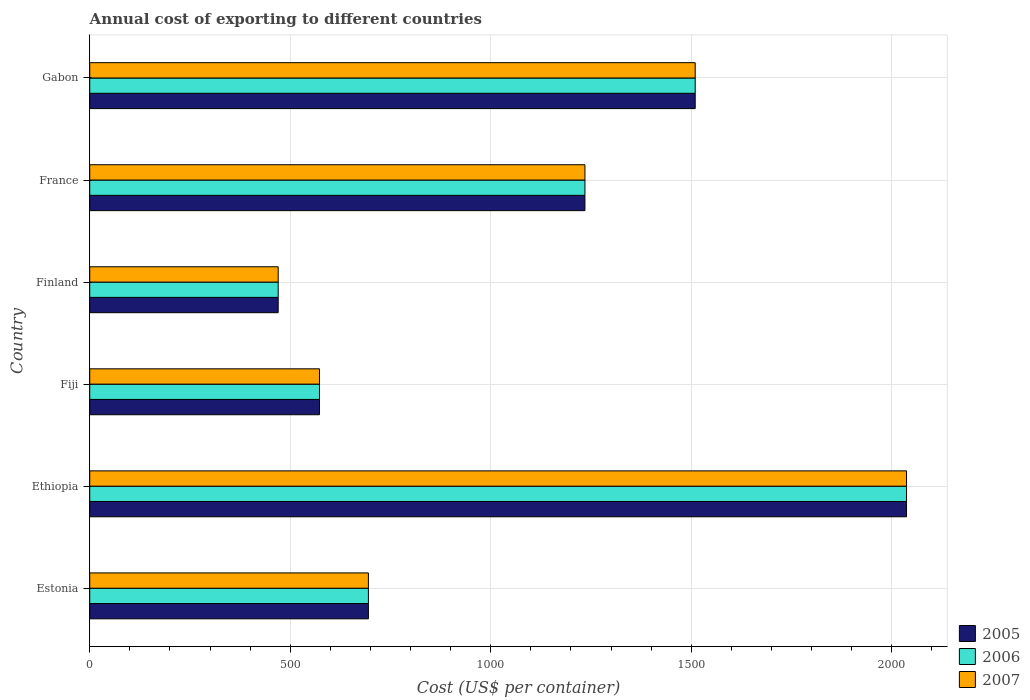How many different coloured bars are there?
Your response must be concise. 3. Are the number of bars per tick equal to the number of legend labels?
Ensure brevity in your answer.  Yes. Are the number of bars on each tick of the Y-axis equal?
Ensure brevity in your answer.  Yes. How many bars are there on the 5th tick from the bottom?
Give a very brief answer. 3. What is the label of the 4th group of bars from the top?
Offer a terse response. Fiji. What is the total annual cost of exporting in 2005 in Fiji?
Give a very brief answer. 573. Across all countries, what is the maximum total annual cost of exporting in 2007?
Provide a short and direct response. 2037. Across all countries, what is the minimum total annual cost of exporting in 2005?
Your answer should be very brief. 470. In which country was the total annual cost of exporting in 2006 maximum?
Ensure brevity in your answer.  Ethiopia. What is the total total annual cost of exporting in 2006 in the graph?
Your answer should be compact. 6520. What is the difference between the total annual cost of exporting in 2005 in Estonia and that in Ethiopia?
Make the answer very short. -1342. What is the difference between the total annual cost of exporting in 2005 in Gabon and the total annual cost of exporting in 2007 in Finland?
Your response must be concise. 1040. What is the average total annual cost of exporting in 2006 per country?
Keep it short and to the point. 1086.67. What is the difference between the total annual cost of exporting in 2007 and total annual cost of exporting in 2005 in Estonia?
Make the answer very short. 0. In how many countries, is the total annual cost of exporting in 2007 greater than 1600 US$?
Give a very brief answer. 1. What is the ratio of the total annual cost of exporting in 2006 in Fiji to that in Gabon?
Offer a terse response. 0.38. Is the total annual cost of exporting in 2006 in Fiji less than that in Finland?
Your answer should be compact. No. Is the difference between the total annual cost of exporting in 2007 in Estonia and Ethiopia greater than the difference between the total annual cost of exporting in 2005 in Estonia and Ethiopia?
Give a very brief answer. No. What is the difference between the highest and the second highest total annual cost of exporting in 2005?
Offer a very short reply. 527. What is the difference between the highest and the lowest total annual cost of exporting in 2007?
Provide a short and direct response. 1567. What does the 3rd bar from the top in Estonia represents?
Your answer should be very brief. 2005. What does the 1st bar from the bottom in Estonia represents?
Provide a short and direct response. 2005. Are all the bars in the graph horizontal?
Keep it short and to the point. Yes. How many countries are there in the graph?
Keep it short and to the point. 6. Does the graph contain any zero values?
Your answer should be compact. No. How are the legend labels stacked?
Keep it short and to the point. Vertical. What is the title of the graph?
Offer a terse response. Annual cost of exporting to different countries. What is the label or title of the X-axis?
Offer a very short reply. Cost (US$ per container). What is the Cost (US$ per container) in 2005 in Estonia?
Give a very brief answer. 695. What is the Cost (US$ per container) in 2006 in Estonia?
Ensure brevity in your answer.  695. What is the Cost (US$ per container) in 2007 in Estonia?
Make the answer very short. 695. What is the Cost (US$ per container) in 2005 in Ethiopia?
Offer a very short reply. 2037. What is the Cost (US$ per container) of 2006 in Ethiopia?
Provide a succinct answer. 2037. What is the Cost (US$ per container) in 2007 in Ethiopia?
Your answer should be very brief. 2037. What is the Cost (US$ per container) of 2005 in Fiji?
Offer a very short reply. 573. What is the Cost (US$ per container) in 2006 in Fiji?
Provide a succinct answer. 573. What is the Cost (US$ per container) in 2007 in Fiji?
Provide a succinct answer. 573. What is the Cost (US$ per container) of 2005 in Finland?
Provide a succinct answer. 470. What is the Cost (US$ per container) in 2006 in Finland?
Ensure brevity in your answer.  470. What is the Cost (US$ per container) of 2007 in Finland?
Offer a very short reply. 470. What is the Cost (US$ per container) of 2005 in France?
Your answer should be very brief. 1235. What is the Cost (US$ per container) of 2006 in France?
Provide a short and direct response. 1235. What is the Cost (US$ per container) in 2007 in France?
Provide a short and direct response. 1235. What is the Cost (US$ per container) of 2005 in Gabon?
Keep it short and to the point. 1510. What is the Cost (US$ per container) in 2006 in Gabon?
Provide a succinct answer. 1510. What is the Cost (US$ per container) of 2007 in Gabon?
Ensure brevity in your answer.  1510. Across all countries, what is the maximum Cost (US$ per container) in 2005?
Offer a terse response. 2037. Across all countries, what is the maximum Cost (US$ per container) of 2006?
Your answer should be very brief. 2037. Across all countries, what is the maximum Cost (US$ per container) of 2007?
Offer a very short reply. 2037. Across all countries, what is the minimum Cost (US$ per container) of 2005?
Provide a succinct answer. 470. Across all countries, what is the minimum Cost (US$ per container) in 2006?
Give a very brief answer. 470. Across all countries, what is the minimum Cost (US$ per container) in 2007?
Ensure brevity in your answer.  470. What is the total Cost (US$ per container) in 2005 in the graph?
Give a very brief answer. 6520. What is the total Cost (US$ per container) of 2006 in the graph?
Give a very brief answer. 6520. What is the total Cost (US$ per container) in 2007 in the graph?
Provide a succinct answer. 6520. What is the difference between the Cost (US$ per container) of 2005 in Estonia and that in Ethiopia?
Make the answer very short. -1342. What is the difference between the Cost (US$ per container) of 2006 in Estonia and that in Ethiopia?
Offer a very short reply. -1342. What is the difference between the Cost (US$ per container) of 2007 in Estonia and that in Ethiopia?
Offer a terse response. -1342. What is the difference between the Cost (US$ per container) of 2005 in Estonia and that in Fiji?
Provide a short and direct response. 122. What is the difference between the Cost (US$ per container) in 2006 in Estonia and that in Fiji?
Give a very brief answer. 122. What is the difference between the Cost (US$ per container) of 2007 in Estonia and that in Fiji?
Ensure brevity in your answer.  122. What is the difference between the Cost (US$ per container) in 2005 in Estonia and that in Finland?
Provide a succinct answer. 225. What is the difference between the Cost (US$ per container) in 2006 in Estonia and that in Finland?
Your response must be concise. 225. What is the difference between the Cost (US$ per container) in 2007 in Estonia and that in Finland?
Provide a succinct answer. 225. What is the difference between the Cost (US$ per container) of 2005 in Estonia and that in France?
Ensure brevity in your answer.  -540. What is the difference between the Cost (US$ per container) in 2006 in Estonia and that in France?
Keep it short and to the point. -540. What is the difference between the Cost (US$ per container) in 2007 in Estonia and that in France?
Offer a terse response. -540. What is the difference between the Cost (US$ per container) in 2005 in Estonia and that in Gabon?
Provide a succinct answer. -815. What is the difference between the Cost (US$ per container) of 2006 in Estonia and that in Gabon?
Offer a very short reply. -815. What is the difference between the Cost (US$ per container) of 2007 in Estonia and that in Gabon?
Ensure brevity in your answer.  -815. What is the difference between the Cost (US$ per container) of 2005 in Ethiopia and that in Fiji?
Give a very brief answer. 1464. What is the difference between the Cost (US$ per container) in 2006 in Ethiopia and that in Fiji?
Make the answer very short. 1464. What is the difference between the Cost (US$ per container) in 2007 in Ethiopia and that in Fiji?
Offer a very short reply. 1464. What is the difference between the Cost (US$ per container) of 2005 in Ethiopia and that in Finland?
Ensure brevity in your answer.  1567. What is the difference between the Cost (US$ per container) in 2006 in Ethiopia and that in Finland?
Offer a terse response. 1567. What is the difference between the Cost (US$ per container) in 2007 in Ethiopia and that in Finland?
Provide a short and direct response. 1567. What is the difference between the Cost (US$ per container) of 2005 in Ethiopia and that in France?
Offer a very short reply. 802. What is the difference between the Cost (US$ per container) in 2006 in Ethiopia and that in France?
Offer a very short reply. 802. What is the difference between the Cost (US$ per container) of 2007 in Ethiopia and that in France?
Offer a very short reply. 802. What is the difference between the Cost (US$ per container) of 2005 in Ethiopia and that in Gabon?
Ensure brevity in your answer.  527. What is the difference between the Cost (US$ per container) of 2006 in Ethiopia and that in Gabon?
Make the answer very short. 527. What is the difference between the Cost (US$ per container) of 2007 in Ethiopia and that in Gabon?
Offer a very short reply. 527. What is the difference between the Cost (US$ per container) of 2005 in Fiji and that in Finland?
Your answer should be very brief. 103. What is the difference between the Cost (US$ per container) of 2006 in Fiji and that in Finland?
Ensure brevity in your answer.  103. What is the difference between the Cost (US$ per container) in 2007 in Fiji and that in Finland?
Your answer should be very brief. 103. What is the difference between the Cost (US$ per container) in 2005 in Fiji and that in France?
Provide a succinct answer. -662. What is the difference between the Cost (US$ per container) of 2006 in Fiji and that in France?
Your answer should be very brief. -662. What is the difference between the Cost (US$ per container) of 2007 in Fiji and that in France?
Ensure brevity in your answer.  -662. What is the difference between the Cost (US$ per container) of 2005 in Fiji and that in Gabon?
Ensure brevity in your answer.  -937. What is the difference between the Cost (US$ per container) of 2006 in Fiji and that in Gabon?
Provide a succinct answer. -937. What is the difference between the Cost (US$ per container) of 2007 in Fiji and that in Gabon?
Give a very brief answer. -937. What is the difference between the Cost (US$ per container) of 2005 in Finland and that in France?
Provide a succinct answer. -765. What is the difference between the Cost (US$ per container) of 2006 in Finland and that in France?
Your answer should be very brief. -765. What is the difference between the Cost (US$ per container) of 2007 in Finland and that in France?
Your answer should be compact. -765. What is the difference between the Cost (US$ per container) in 2005 in Finland and that in Gabon?
Keep it short and to the point. -1040. What is the difference between the Cost (US$ per container) of 2006 in Finland and that in Gabon?
Your answer should be compact. -1040. What is the difference between the Cost (US$ per container) in 2007 in Finland and that in Gabon?
Keep it short and to the point. -1040. What is the difference between the Cost (US$ per container) of 2005 in France and that in Gabon?
Keep it short and to the point. -275. What is the difference between the Cost (US$ per container) in 2006 in France and that in Gabon?
Ensure brevity in your answer.  -275. What is the difference between the Cost (US$ per container) of 2007 in France and that in Gabon?
Your response must be concise. -275. What is the difference between the Cost (US$ per container) in 2005 in Estonia and the Cost (US$ per container) in 2006 in Ethiopia?
Offer a very short reply. -1342. What is the difference between the Cost (US$ per container) in 2005 in Estonia and the Cost (US$ per container) in 2007 in Ethiopia?
Your answer should be compact. -1342. What is the difference between the Cost (US$ per container) in 2006 in Estonia and the Cost (US$ per container) in 2007 in Ethiopia?
Offer a very short reply. -1342. What is the difference between the Cost (US$ per container) in 2005 in Estonia and the Cost (US$ per container) in 2006 in Fiji?
Provide a succinct answer. 122. What is the difference between the Cost (US$ per container) in 2005 in Estonia and the Cost (US$ per container) in 2007 in Fiji?
Provide a succinct answer. 122. What is the difference between the Cost (US$ per container) in 2006 in Estonia and the Cost (US$ per container) in 2007 in Fiji?
Your response must be concise. 122. What is the difference between the Cost (US$ per container) in 2005 in Estonia and the Cost (US$ per container) in 2006 in Finland?
Your response must be concise. 225. What is the difference between the Cost (US$ per container) of 2005 in Estonia and the Cost (US$ per container) of 2007 in Finland?
Provide a succinct answer. 225. What is the difference between the Cost (US$ per container) in 2006 in Estonia and the Cost (US$ per container) in 2007 in Finland?
Your response must be concise. 225. What is the difference between the Cost (US$ per container) of 2005 in Estonia and the Cost (US$ per container) of 2006 in France?
Make the answer very short. -540. What is the difference between the Cost (US$ per container) of 2005 in Estonia and the Cost (US$ per container) of 2007 in France?
Give a very brief answer. -540. What is the difference between the Cost (US$ per container) of 2006 in Estonia and the Cost (US$ per container) of 2007 in France?
Offer a terse response. -540. What is the difference between the Cost (US$ per container) in 2005 in Estonia and the Cost (US$ per container) in 2006 in Gabon?
Give a very brief answer. -815. What is the difference between the Cost (US$ per container) in 2005 in Estonia and the Cost (US$ per container) in 2007 in Gabon?
Offer a very short reply. -815. What is the difference between the Cost (US$ per container) in 2006 in Estonia and the Cost (US$ per container) in 2007 in Gabon?
Offer a terse response. -815. What is the difference between the Cost (US$ per container) of 2005 in Ethiopia and the Cost (US$ per container) of 2006 in Fiji?
Keep it short and to the point. 1464. What is the difference between the Cost (US$ per container) of 2005 in Ethiopia and the Cost (US$ per container) of 2007 in Fiji?
Make the answer very short. 1464. What is the difference between the Cost (US$ per container) in 2006 in Ethiopia and the Cost (US$ per container) in 2007 in Fiji?
Provide a succinct answer. 1464. What is the difference between the Cost (US$ per container) of 2005 in Ethiopia and the Cost (US$ per container) of 2006 in Finland?
Your answer should be very brief. 1567. What is the difference between the Cost (US$ per container) of 2005 in Ethiopia and the Cost (US$ per container) of 2007 in Finland?
Ensure brevity in your answer.  1567. What is the difference between the Cost (US$ per container) in 2006 in Ethiopia and the Cost (US$ per container) in 2007 in Finland?
Your response must be concise. 1567. What is the difference between the Cost (US$ per container) in 2005 in Ethiopia and the Cost (US$ per container) in 2006 in France?
Offer a terse response. 802. What is the difference between the Cost (US$ per container) in 2005 in Ethiopia and the Cost (US$ per container) in 2007 in France?
Give a very brief answer. 802. What is the difference between the Cost (US$ per container) of 2006 in Ethiopia and the Cost (US$ per container) of 2007 in France?
Provide a succinct answer. 802. What is the difference between the Cost (US$ per container) in 2005 in Ethiopia and the Cost (US$ per container) in 2006 in Gabon?
Your answer should be very brief. 527. What is the difference between the Cost (US$ per container) in 2005 in Ethiopia and the Cost (US$ per container) in 2007 in Gabon?
Offer a terse response. 527. What is the difference between the Cost (US$ per container) of 2006 in Ethiopia and the Cost (US$ per container) of 2007 in Gabon?
Your response must be concise. 527. What is the difference between the Cost (US$ per container) in 2005 in Fiji and the Cost (US$ per container) in 2006 in Finland?
Offer a terse response. 103. What is the difference between the Cost (US$ per container) of 2005 in Fiji and the Cost (US$ per container) of 2007 in Finland?
Your answer should be very brief. 103. What is the difference between the Cost (US$ per container) in 2006 in Fiji and the Cost (US$ per container) in 2007 in Finland?
Make the answer very short. 103. What is the difference between the Cost (US$ per container) of 2005 in Fiji and the Cost (US$ per container) of 2006 in France?
Your response must be concise. -662. What is the difference between the Cost (US$ per container) in 2005 in Fiji and the Cost (US$ per container) in 2007 in France?
Provide a short and direct response. -662. What is the difference between the Cost (US$ per container) in 2006 in Fiji and the Cost (US$ per container) in 2007 in France?
Give a very brief answer. -662. What is the difference between the Cost (US$ per container) of 2005 in Fiji and the Cost (US$ per container) of 2006 in Gabon?
Keep it short and to the point. -937. What is the difference between the Cost (US$ per container) of 2005 in Fiji and the Cost (US$ per container) of 2007 in Gabon?
Keep it short and to the point. -937. What is the difference between the Cost (US$ per container) of 2006 in Fiji and the Cost (US$ per container) of 2007 in Gabon?
Offer a very short reply. -937. What is the difference between the Cost (US$ per container) in 2005 in Finland and the Cost (US$ per container) in 2006 in France?
Make the answer very short. -765. What is the difference between the Cost (US$ per container) in 2005 in Finland and the Cost (US$ per container) in 2007 in France?
Give a very brief answer. -765. What is the difference between the Cost (US$ per container) in 2006 in Finland and the Cost (US$ per container) in 2007 in France?
Provide a succinct answer. -765. What is the difference between the Cost (US$ per container) in 2005 in Finland and the Cost (US$ per container) in 2006 in Gabon?
Give a very brief answer. -1040. What is the difference between the Cost (US$ per container) in 2005 in Finland and the Cost (US$ per container) in 2007 in Gabon?
Offer a very short reply. -1040. What is the difference between the Cost (US$ per container) in 2006 in Finland and the Cost (US$ per container) in 2007 in Gabon?
Keep it short and to the point. -1040. What is the difference between the Cost (US$ per container) in 2005 in France and the Cost (US$ per container) in 2006 in Gabon?
Give a very brief answer. -275. What is the difference between the Cost (US$ per container) in 2005 in France and the Cost (US$ per container) in 2007 in Gabon?
Offer a terse response. -275. What is the difference between the Cost (US$ per container) of 2006 in France and the Cost (US$ per container) of 2007 in Gabon?
Keep it short and to the point. -275. What is the average Cost (US$ per container) of 2005 per country?
Make the answer very short. 1086.67. What is the average Cost (US$ per container) in 2006 per country?
Your response must be concise. 1086.67. What is the average Cost (US$ per container) of 2007 per country?
Give a very brief answer. 1086.67. What is the difference between the Cost (US$ per container) of 2005 and Cost (US$ per container) of 2006 in Ethiopia?
Your answer should be compact. 0. What is the difference between the Cost (US$ per container) of 2005 and Cost (US$ per container) of 2007 in Ethiopia?
Offer a terse response. 0. What is the difference between the Cost (US$ per container) in 2005 and Cost (US$ per container) in 2006 in Fiji?
Keep it short and to the point. 0. What is the difference between the Cost (US$ per container) in 2005 and Cost (US$ per container) in 2007 in Fiji?
Make the answer very short. 0. What is the difference between the Cost (US$ per container) of 2005 and Cost (US$ per container) of 2006 in Finland?
Provide a succinct answer. 0. What is the difference between the Cost (US$ per container) in 2006 and Cost (US$ per container) in 2007 in Finland?
Offer a very short reply. 0. What is the difference between the Cost (US$ per container) of 2005 and Cost (US$ per container) of 2006 in France?
Your answer should be very brief. 0. What is the difference between the Cost (US$ per container) in 2005 and Cost (US$ per container) in 2007 in France?
Your answer should be compact. 0. What is the ratio of the Cost (US$ per container) in 2005 in Estonia to that in Ethiopia?
Offer a very short reply. 0.34. What is the ratio of the Cost (US$ per container) in 2006 in Estonia to that in Ethiopia?
Your response must be concise. 0.34. What is the ratio of the Cost (US$ per container) in 2007 in Estonia to that in Ethiopia?
Offer a terse response. 0.34. What is the ratio of the Cost (US$ per container) of 2005 in Estonia to that in Fiji?
Your answer should be very brief. 1.21. What is the ratio of the Cost (US$ per container) of 2006 in Estonia to that in Fiji?
Give a very brief answer. 1.21. What is the ratio of the Cost (US$ per container) in 2007 in Estonia to that in Fiji?
Provide a succinct answer. 1.21. What is the ratio of the Cost (US$ per container) in 2005 in Estonia to that in Finland?
Your answer should be compact. 1.48. What is the ratio of the Cost (US$ per container) of 2006 in Estonia to that in Finland?
Ensure brevity in your answer.  1.48. What is the ratio of the Cost (US$ per container) of 2007 in Estonia to that in Finland?
Make the answer very short. 1.48. What is the ratio of the Cost (US$ per container) of 2005 in Estonia to that in France?
Make the answer very short. 0.56. What is the ratio of the Cost (US$ per container) of 2006 in Estonia to that in France?
Ensure brevity in your answer.  0.56. What is the ratio of the Cost (US$ per container) of 2007 in Estonia to that in France?
Your response must be concise. 0.56. What is the ratio of the Cost (US$ per container) of 2005 in Estonia to that in Gabon?
Give a very brief answer. 0.46. What is the ratio of the Cost (US$ per container) in 2006 in Estonia to that in Gabon?
Your answer should be compact. 0.46. What is the ratio of the Cost (US$ per container) of 2007 in Estonia to that in Gabon?
Your response must be concise. 0.46. What is the ratio of the Cost (US$ per container) in 2005 in Ethiopia to that in Fiji?
Keep it short and to the point. 3.56. What is the ratio of the Cost (US$ per container) of 2006 in Ethiopia to that in Fiji?
Give a very brief answer. 3.56. What is the ratio of the Cost (US$ per container) of 2007 in Ethiopia to that in Fiji?
Give a very brief answer. 3.56. What is the ratio of the Cost (US$ per container) of 2005 in Ethiopia to that in Finland?
Your answer should be compact. 4.33. What is the ratio of the Cost (US$ per container) in 2006 in Ethiopia to that in Finland?
Keep it short and to the point. 4.33. What is the ratio of the Cost (US$ per container) of 2007 in Ethiopia to that in Finland?
Your answer should be compact. 4.33. What is the ratio of the Cost (US$ per container) in 2005 in Ethiopia to that in France?
Keep it short and to the point. 1.65. What is the ratio of the Cost (US$ per container) in 2006 in Ethiopia to that in France?
Your response must be concise. 1.65. What is the ratio of the Cost (US$ per container) of 2007 in Ethiopia to that in France?
Keep it short and to the point. 1.65. What is the ratio of the Cost (US$ per container) of 2005 in Ethiopia to that in Gabon?
Your answer should be compact. 1.35. What is the ratio of the Cost (US$ per container) of 2006 in Ethiopia to that in Gabon?
Offer a terse response. 1.35. What is the ratio of the Cost (US$ per container) of 2007 in Ethiopia to that in Gabon?
Offer a terse response. 1.35. What is the ratio of the Cost (US$ per container) of 2005 in Fiji to that in Finland?
Offer a very short reply. 1.22. What is the ratio of the Cost (US$ per container) in 2006 in Fiji to that in Finland?
Provide a short and direct response. 1.22. What is the ratio of the Cost (US$ per container) in 2007 in Fiji to that in Finland?
Give a very brief answer. 1.22. What is the ratio of the Cost (US$ per container) in 2005 in Fiji to that in France?
Make the answer very short. 0.46. What is the ratio of the Cost (US$ per container) of 2006 in Fiji to that in France?
Make the answer very short. 0.46. What is the ratio of the Cost (US$ per container) of 2007 in Fiji to that in France?
Give a very brief answer. 0.46. What is the ratio of the Cost (US$ per container) in 2005 in Fiji to that in Gabon?
Give a very brief answer. 0.38. What is the ratio of the Cost (US$ per container) in 2006 in Fiji to that in Gabon?
Offer a terse response. 0.38. What is the ratio of the Cost (US$ per container) of 2007 in Fiji to that in Gabon?
Your answer should be compact. 0.38. What is the ratio of the Cost (US$ per container) of 2005 in Finland to that in France?
Your answer should be very brief. 0.38. What is the ratio of the Cost (US$ per container) of 2006 in Finland to that in France?
Your answer should be compact. 0.38. What is the ratio of the Cost (US$ per container) in 2007 in Finland to that in France?
Make the answer very short. 0.38. What is the ratio of the Cost (US$ per container) of 2005 in Finland to that in Gabon?
Provide a short and direct response. 0.31. What is the ratio of the Cost (US$ per container) in 2006 in Finland to that in Gabon?
Provide a succinct answer. 0.31. What is the ratio of the Cost (US$ per container) in 2007 in Finland to that in Gabon?
Offer a very short reply. 0.31. What is the ratio of the Cost (US$ per container) of 2005 in France to that in Gabon?
Give a very brief answer. 0.82. What is the ratio of the Cost (US$ per container) of 2006 in France to that in Gabon?
Give a very brief answer. 0.82. What is the ratio of the Cost (US$ per container) of 2007 in France to that in Gabon?
Provide a succinct answer. 0.82. What is the difference between the highest and the second highest Cost (US$ per container) in 2005?
Your response must be concise. 527. What is the difference between the highest and the second highest Cost (US$ per container) of 2006?
Your response must be concise. 527. What is the difference between the highest and the second highest Cost (US$ per container) of 2007?
Give a very brief answer. 527. What is the difference between the highest and the lowest Cost (US$ per container) in 2005?
Your answer should be very brief. 1567. What is the difference between the highest and the lowest Cost (US$ per container) in 2006?
Provide a succinct answer. 1567. What is the difference between the highest and the lowest Cost (US$ per container) of 2007?
Your answer should be compact. 1567. 